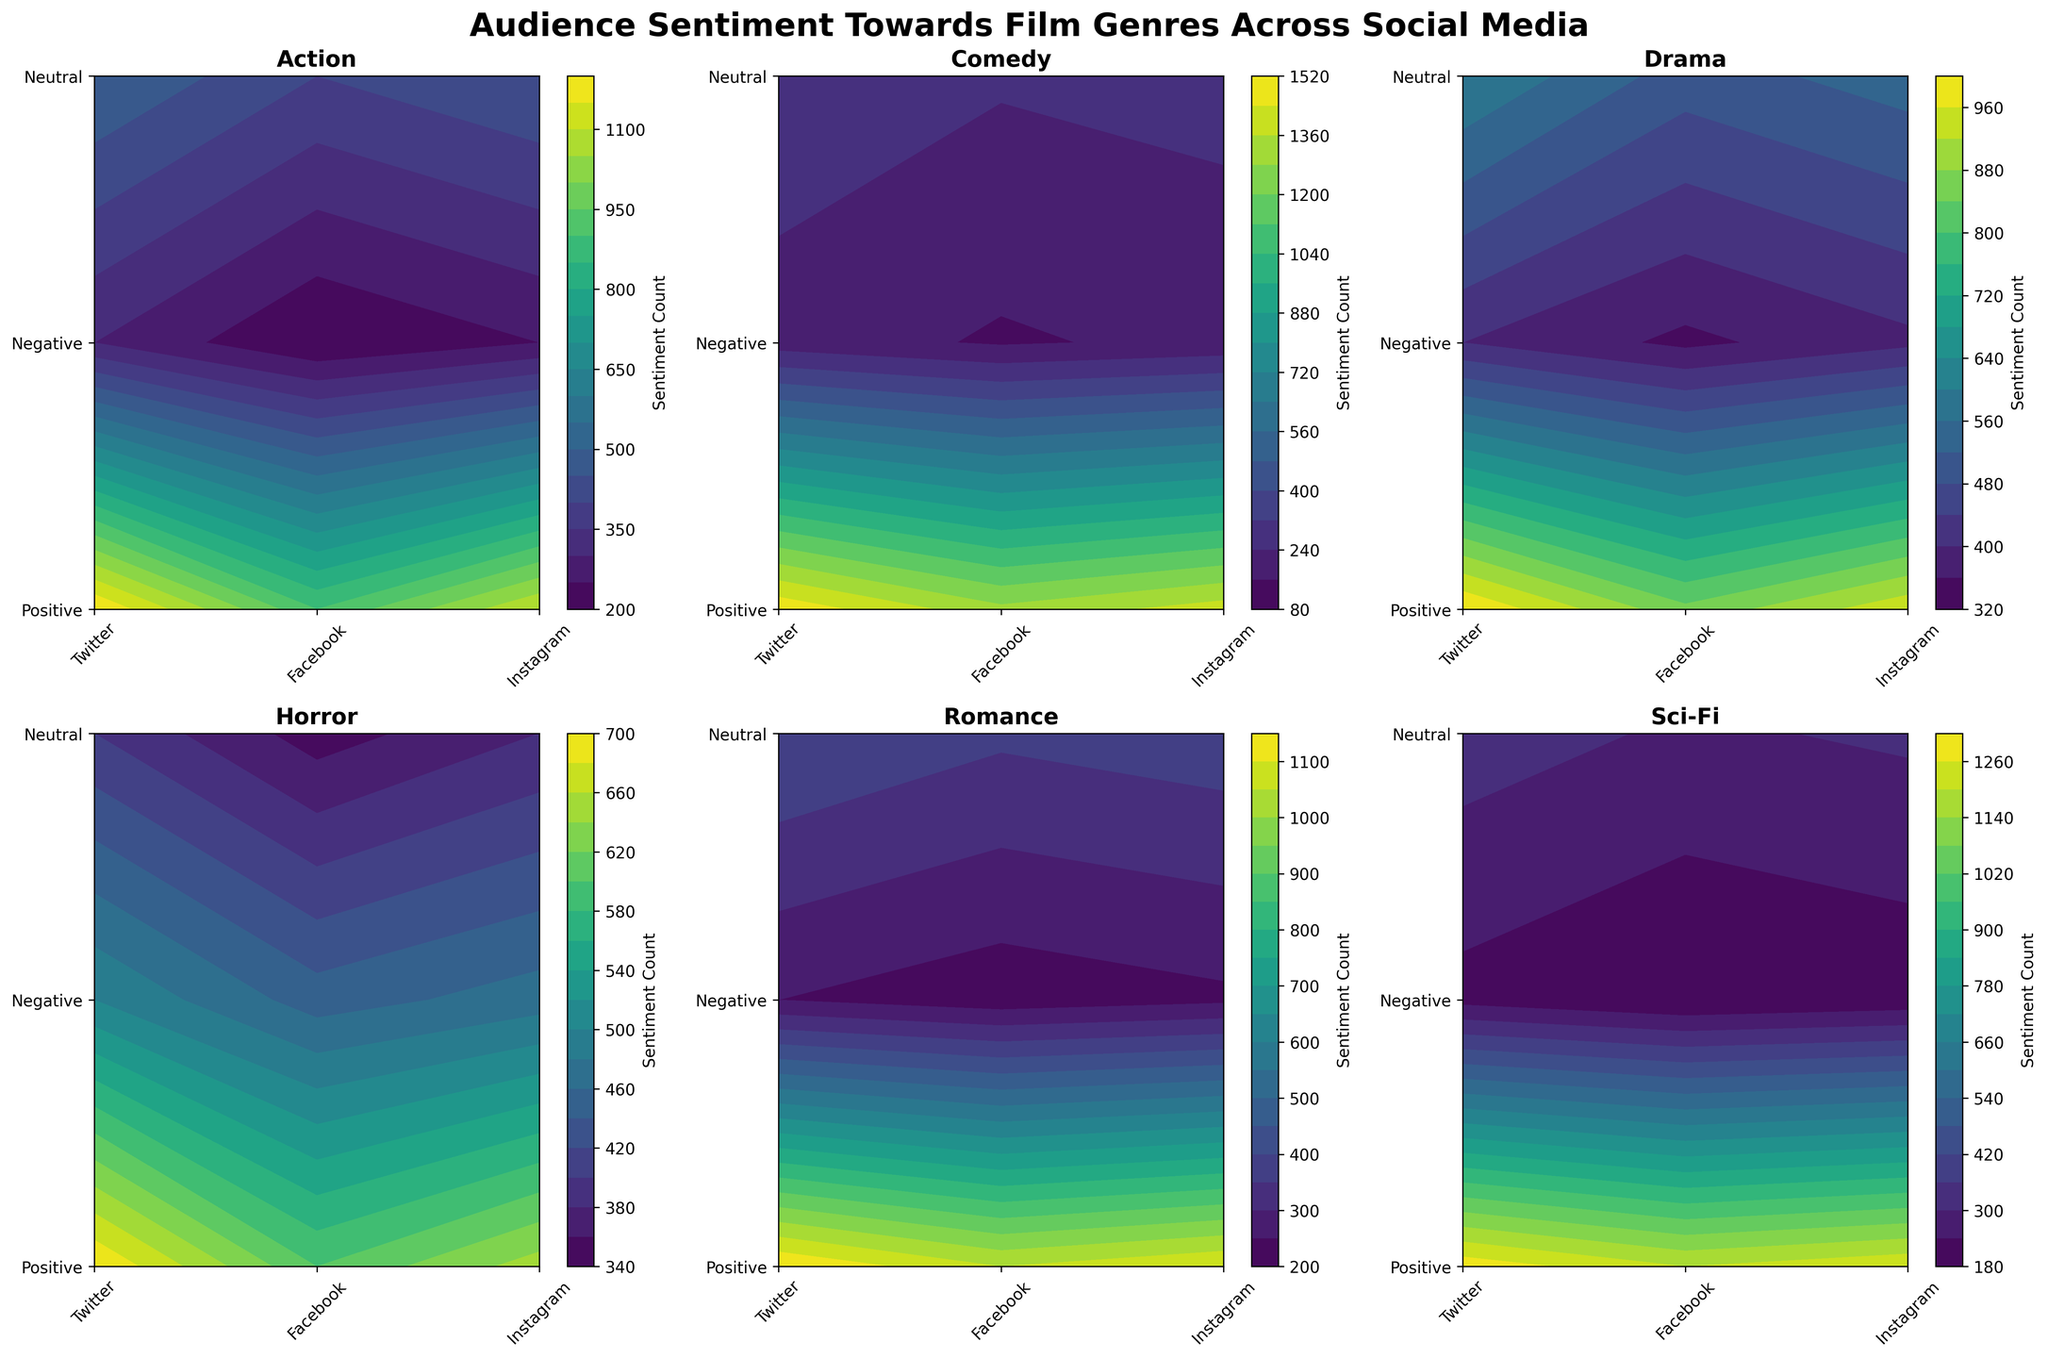What is the title of the figure? The title is written at the top of the figure.
Answer: Audience Sentiment Towards Film Genres Across Social Media Which social media platform has the highest positive sentiment for Action films? By looking at the "Action" subplot and the "Positive" row, we can compare the contour levels for Twitter, Facebook, and Instagram.
Answer: Twitter Does Comedy receive more negative sentiment on Instagram or Facebook? In the Comedy subplot, compare the values at the "Negative" row for Instagram and Facebook.
Answer: Instagram Which genre has the lowest neutral sentiment on Twitter? Check the "Neutral" row across the subplots for Twitter and identify the subplot with the lowest contour level.
Answer: Comedy Count the total number of genres analyzed in the figure. Each subplot represents a genre, and we simply count the number of subplots. There are six subplots, therefore, six genres are analyzed.
Answer: 6 How does the positive sentiment for Sci-Fi on Facebook compare to Instagram? Examine the Sci-Fi subplot and the "Positive" row for both Facebook and Instagram. Compare the contour levels.
Answer: Facebook has a lower positive sentiment than Instagram What is the overall trend of neutral sentiment across different platforms for Horror? Look at the Horror subplot, specifically the neutral row. The values are slightly different for Twitter, Facebook, and Instagram but can be visually inspected for an overall trend.
Answer: Similar across platforms What is the platform with the highest negative sentiment for Drama? In the Drama subplot, compare the contour levels in the "Negative" row across Twitter, Facebook, and Instagram.
Answer: Twitter Which genre has relatively balanced sentiment (positive, negative, and neutral) on Facebook? Check the balance in contour levels for positive, negative, and neutral rows in each subplot focusing on the Facebook column.
Answer: Drama Compare the positive sentiment for Romance on Twitter and Instagram. Which one is higher? In the Romance subplot, check the contour levels for the "Positive" row on Twitter and Instagram.
Answer: Twitter 